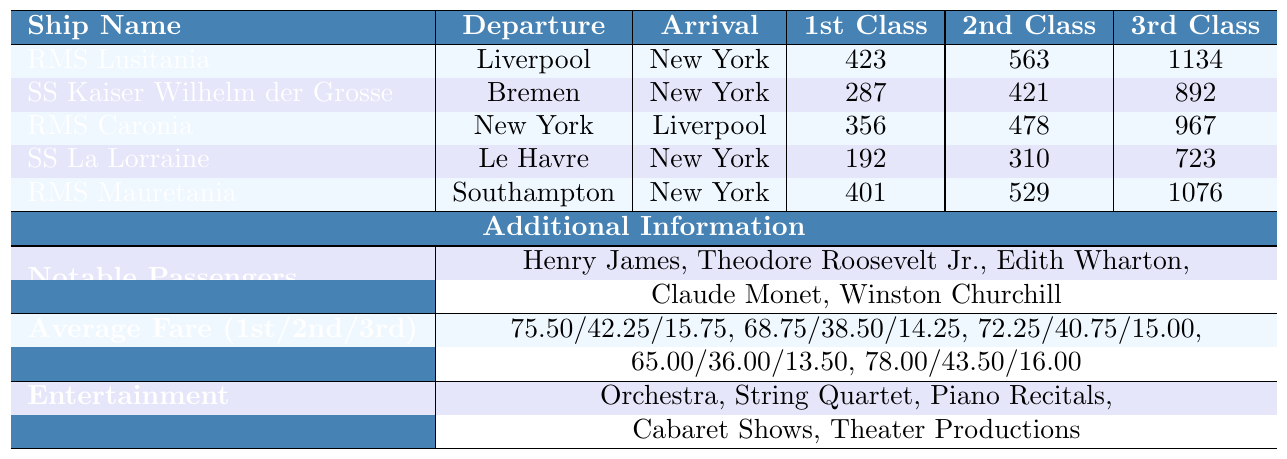What is the name of the captain for the RMS Mauretania? The table lists the captain names associated with each ship, and for the RMS Mauretania, the captain's name is John Pritchard.
Answer: John Pritchard How many first-class passengers were on the SS Kaiser Wilhelm der Grosse? The table shows that the SS Kaiser Wilhelm der Grosse had 287 first-class passengers listed under its relevant column.
Answer: 287 What is the total number of third-class passengers across all ships? To find the total number of third-class passengers, we sum the values: 1134 (RMS Lusitania) + 892 (SS Kaiser Wilhelm der Grosse) + 967 (RMS Caronia) + 723 (SS La Lorraine) + 1076 (RMS Mauretania) = 4792.
Answer: 4792 Which ship had the highest average fare for first-class passengers? By comparing the average fares for first-class passengers across all ships, the RMS Mauretania has the highest average fare at 78.00.
Answer: RMS Mauretania Did the RMS Lusitania have any notable passengers? According to the table, the RMS Lusitania is listed along with notable passengers, specifically Henry James.
Answer: Yes Which ship had the most passengers in total? To find the total passengers for each ship, we add first, second, and third class passengers. For RMS Lusitania: 423 + 563 + 1134 = 2120; SS Kaiser Wilhelm der Grosse: 287 + 421 + 892 = 1600; RMS Caronia: 356 + 478 + 967 = 1801; SS La Lorraine: 192 + 310 + 723 = 1225; and RMS Mauretania: 401 + 529 + 1076 = 2006. The RMS Lusitania had the highest total at 2120.
Answer: RMS Lusitania What average fare is charged for second-class passengers on the SS La Lorraine? The average fare for second-class passengers on the SS La Lorraine is noted in the table as 36.00.
Answer: 36.00 Are there more third-class passengers on the RMS Caronia or the RMS Mauretania? The table shows that RMS Caronia had 967 third-class passengers while RMS Mauretania had 1076. Since 1076 is greater than 967, RMS Mauretania has more.
Answer: RMS Mauretania What is the difference in the average fare for first-class passengers between the RMS Lusitania and the RMS Caronia? To find the difference, subtract the average fare of the RMS Caronia (72.25) from that of the RMS Lusitania (75.50). The difference is 75.50 - 72.25 = 3.25.
Answer: 3.25 Which ship departs from Le Havre and what is its arrival port? SS La Lorraine departs from Le Havre and its arrival port is New York, as shown in the table.
Answer: New York What nationalities were most commonly found among the passengers of the RMS Lusitania? The passenger nationalities for the RMS Lusitania were British, American, and German, as specified in the table.
Answer: British, American, German 